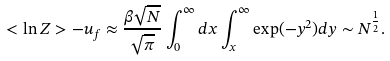Convert formula to latex. <formula><loc_0><loc_0><loc_500><loc_500>< \ln Z > - u _ { f } \approx \frac { \beta \sqrt { N } } { \sqrt { \pi } } \int _ { 0 } ^ { \infty } d x \int _ { x } ^ { \infty } \exp ( - y ^ { 2 } ) d y \sim N ^ { \frac { 1 } { 2 } } .</formula> 